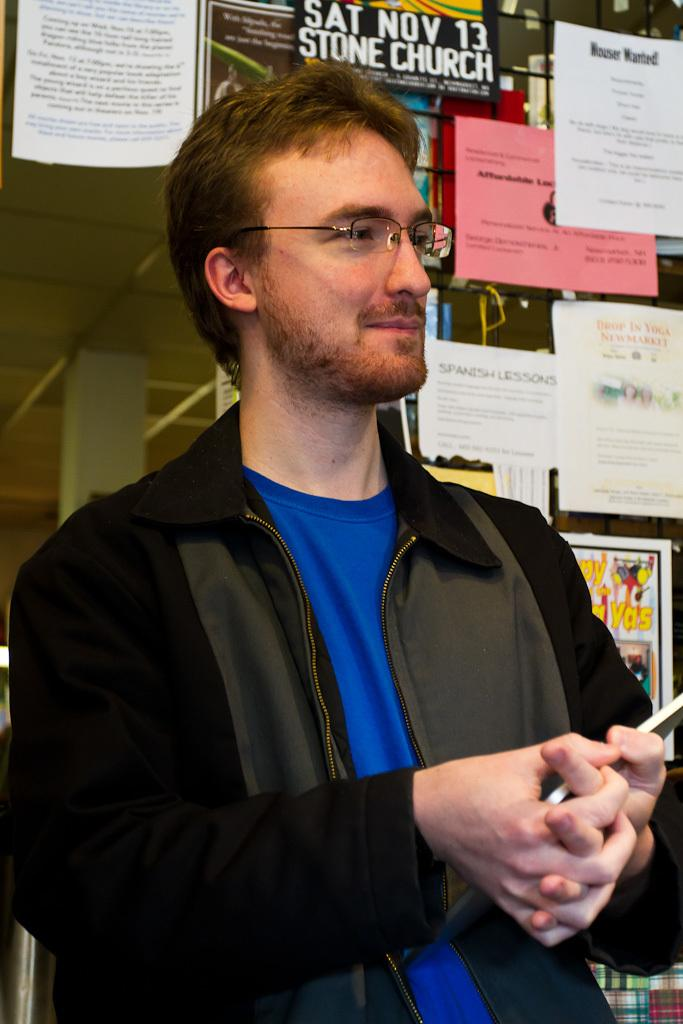What can be seen in the image? There is a person in the image. Can you describe the person's appearance? The person is wearing spectacles. What is the person holding in the image? The person is holding an object. What can be seen in the background of the image? There is a pillar, a rod, posters, a roof, and some unspecified objects in the background of the image. Can you describe the unspecified objects in the background? Unfortunately, the facts provided do not specify the nature of the unspecified objects. Can you tell me how many sinks are visible in the image? There are no sinks visible in the image. What type of thing is floating in the lake in the image? There is no lake present in the image, so there cannot be any floating things. 